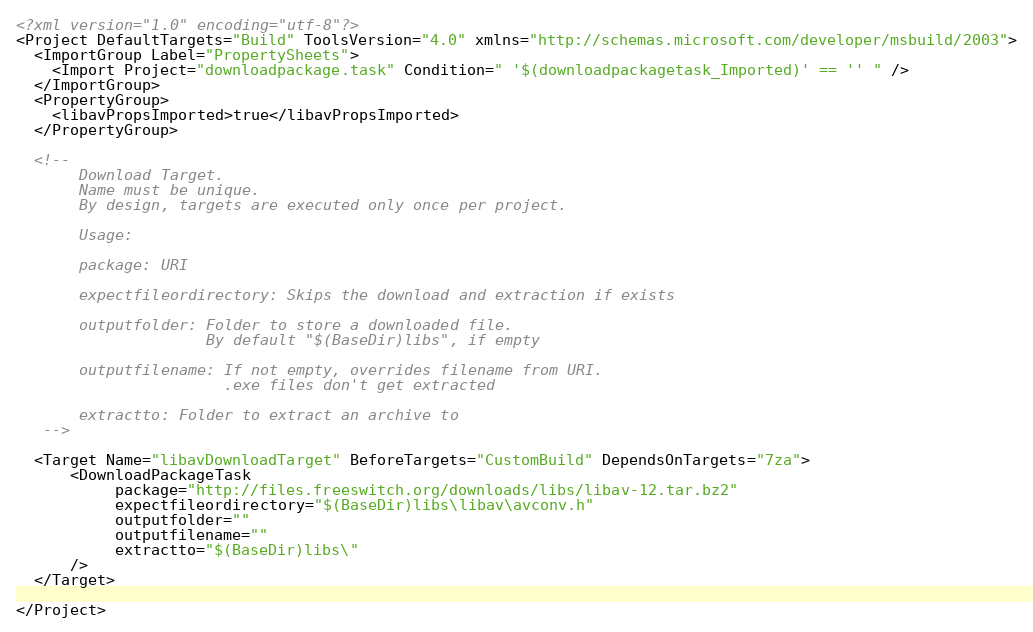<code> <loc_0><loc_0><loc_500><loc_500><_XML_><?xml version="1.0" encoding="utf-8"?>
<Project DefaultTargets="Build" ToolsVersion="4.0" xmlns="http://schemas.microsoft.com/developer/msbuild/2003">
  <ImportGroup Label="PropertySheets">
    <Import Project="downloadpackage.task" Condition=" '$(downloadpackagetask_Imported)' == '' " />
  </ImportGroup>
  <PropertyGroup>
    <libavPropsImported>true</libavPropsImported>
  </PropertyGroup>

  <!--
       Download Target.
       Name must be unique.
       By design, targets are executed only once per project.

       Usage:

       package: URI

       expectfileordirectory: Skips the download and extraction if exists

       outputfolder: Folder to store a downloaded file.
                     By default "$(BaseDir)libs", if empty

       outputfilename: If not empty, overrides filename from URI.
                       .exe files don't get extracted

       extractto: Folder to extract an archive to
   -->

  <Target Name="libavDownloadTarget" BeforeTargets="CustomBuild" DependsOnTargets="7za">
      <DownloadPackageTask
           package="http://files.freeswitch.org/downloads/libs/libav-12.tar.bz2"
           expectfileordirectory="$(BaseDir)libs\libav\avconv.h"
           outputfolder=""
           outputfilename=""
           extractto="$(BaseDir)libs\"
      />
  </Target>

</Project>
</code> 